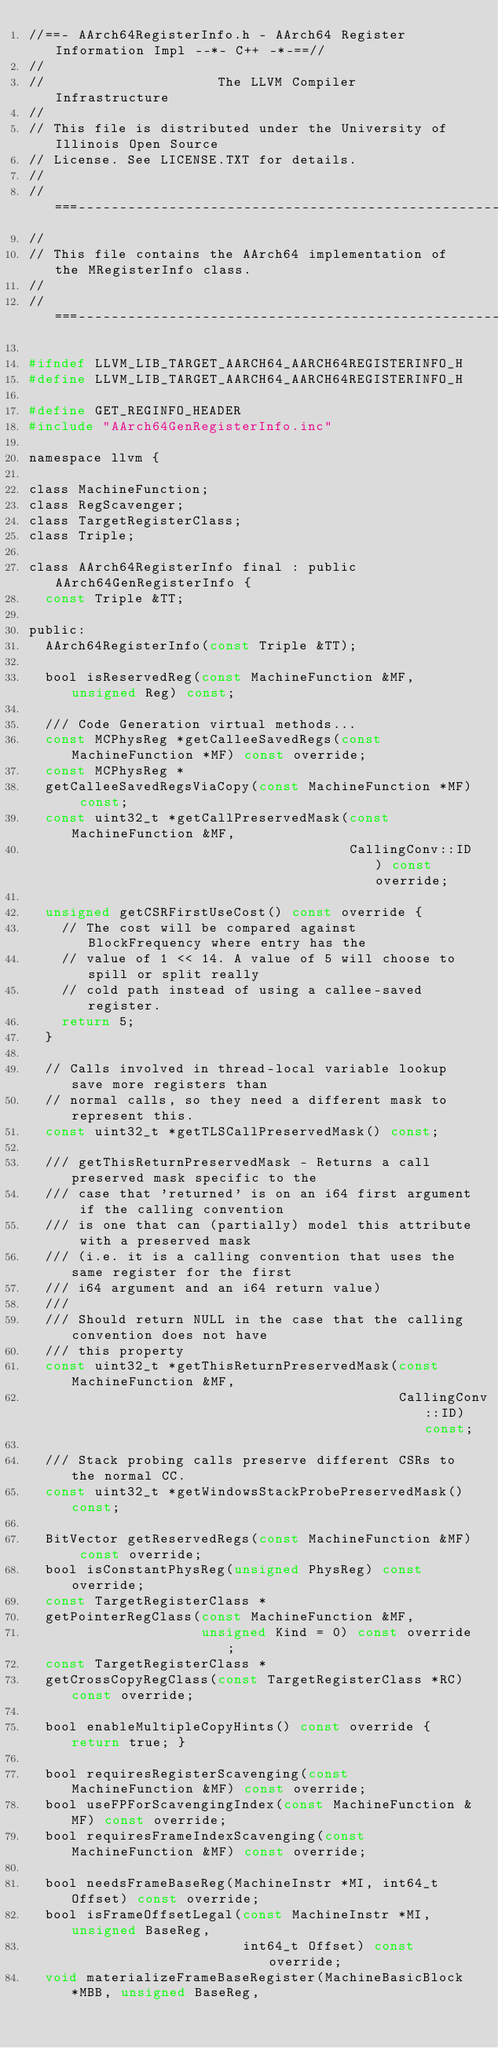<code> <loc_0><loc_0><loc_500><loc_500><_C_>//==- AArch64RegisterInfo.h - AArch64 Register Information Impl --*- C++ -*-==//
//
//                     The LLVM Compiler Infrastructure
//
// This file is distributed under the University of Illinois Open Source
// License. See LICENSE.TXT for details.
//
//===----------------------------------------------------------------------===//
//
// This file contains the AArch64 implementation of the MRegisterInfo class.
//
//===----------------------------------------------------------------------===//

#ifndef LLVM_LIB_TARGET_AARCH64_AARCH64REGISTERINFO_H
#define LLVM_LIB_TARGET_AARCH64_AARCH64REGISTERINFO_H

#define GET_REGINFO_HEADER
#include "AArch64GenRegisterInfo.inc"

namespace llvm {

class MachineFunction;
class RegScavenger;
class TargetRegisterClass;
class Triple;

class AArch64RegisterInfo final : public AArch64GenRegisterInfo {
  const Triple &TT;

public:
  AArch64RegisterInfo(const Triple &TT);

  bool isReservedReg(const MachineFunction &MF, unsigned Reg) const;

  /// Code Generation virtual methods...
  const MCPhysReg *getCalleeSavedRegs(const MachineFunction *MF) const override;
  const MCPhysReg *
  getCalleeSavedRegsViaCopy(const MachineFunction *MF) const;
  const uint32_t *getCallPreservedMask(const MachineFunction &MF,
                                       CallingConv::ID) const override;

  unsigned getCSRFirstUseCost() const override {
    // The cost will be compared against BlockFrequency where entry has the
    // value of 1 << 14. A value of 5 will choose to spill or split really
    // cold path instead of using a callee-saved register.
    return 5;
  }

  // Calls involved in thread-local variable lookup save more registers than
  // normal calls, so they need a different mask to represent this.
  const uint32_t *getTLSCallPreservedMask() const;

  /// getThisReturnPreservedMask - Returns a call preserved mask specific to the
  /// case that 'returned' is on an i64 first argument if the calling convention
  /// is one that can (partially) model this attribute with a preserved mask
  /// (i.e. it is a calling convention that uses the same register for the first
  /// i64 argument and an i64 return value)
  ///
  /// Should return NULL in the case that the calling convention does not have
  /// this property
  const uint32_t *getThisReturnPreservedMask(const MachineFunction &MF,
                                             CallingConv::ID) const;

  /// Stack probing calls preserve different CSRs to the normal CC.
  const uint32_t *getWindowsStackProbePreservedMask() const;

  BitVector getReservedRegs(const MachineFunction &MF) const override;
  bool isConstantPhysReg(unsigned PhysReg) const override;
  const TargetRegisterClass *
  getPointerRegClass(const MachineFunction &MF,
                     unsigned Kind = 0) const override;
  const TargetRegisterClass *
  getCrossCopyRegClass(const TargetRegisterClass *RC) const override;

  bool enableMultipleCopyHints() const override { return true; }

  bool requiresRegisterScavenging(const MachineFunction &MF) const override;
  bool useFPForScavengingIndex(const MachineFunction &MF) const override;
  bool requiresFrameIndexScavenging(const MachineFunction &MF) const override;

  bool needsFrameBaseReg(MachineInstr *MI, int64_t Offset) const override;
  bool isFrameOffsetLegal(const MachineInstr *MI, unsigned BaseReg,
                          int64_t Offset) const override;
  void materializeFrameBaseRegister(MachineBasicBlock *MBB, unsigned BaseReg,</code> 